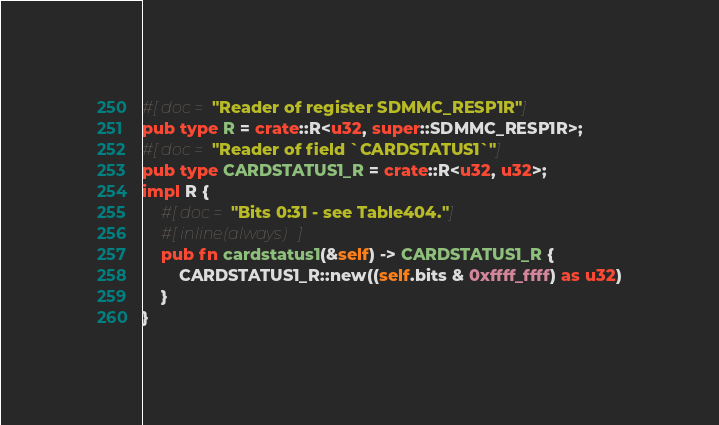Convert code to text. <code><loc_0><loc_0><loc_500><loc_500><_Rust_>#[doc = "Reader of register SDMMC_RESP1R"]
pub type R = crate::R<u32, super::SDMMC_RESP1R>;
#[doc = "Reader of field `CARDSTATUS1`"]
pub type CARDSTATUS1_R = crate::R<u32, u32>;
impl R {
    #[doc = "Bits 0:31 - see Table404."]
    #[inline(always)]
    pub fn cardstatus1(&self) -> CARDSTATUS1_R {
        CARDSTATUS1_R::new((self.bits & 0xffff_ffff) as u32)
    }
}
</code> 